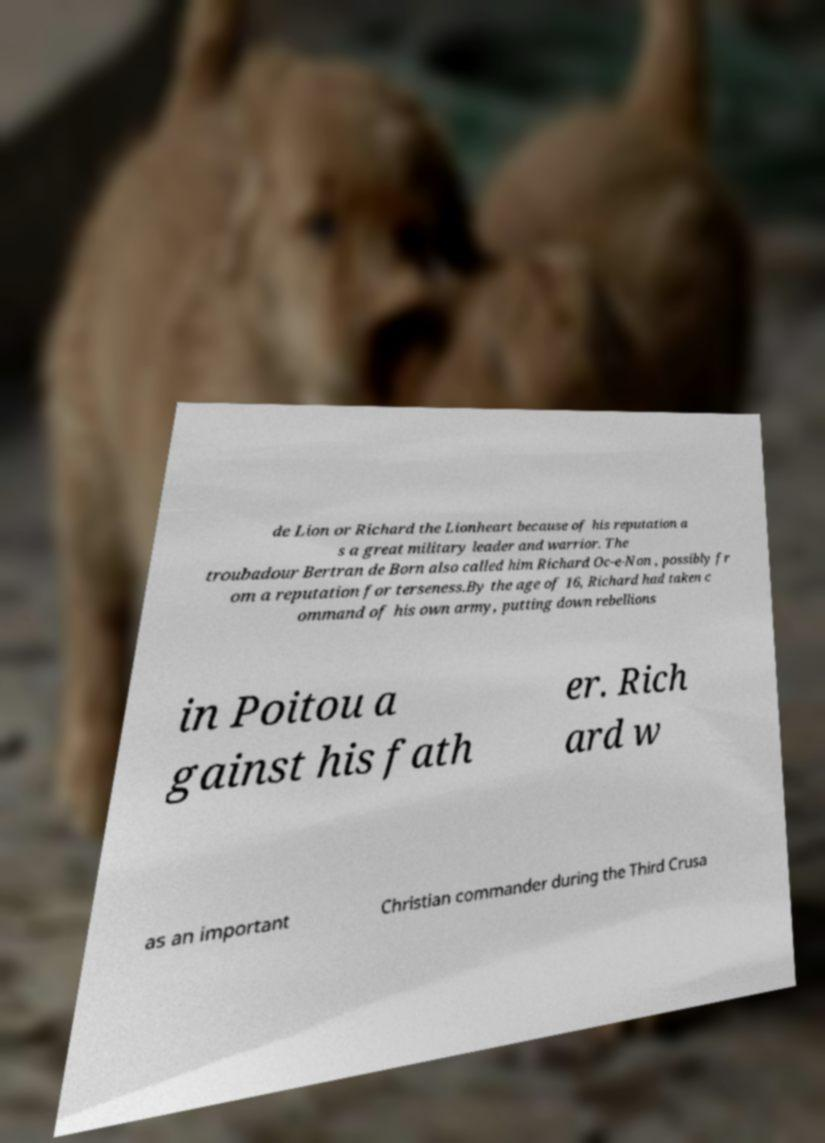Can you read and provide the text displayed in the image?This photo seems to have some interesting text. Can you extract and type it out for me? de Lion or Richard the Lionheart because of his reputation a s a great military leader and warrior. The troubadour Bertran de Born also called him Richard Oc-e-Non , possibly fr om a reputation for terseness.By the age of 16, Richard had taken c ommand of his own army, putting down rebellions in Poitou a gainst his fath er. Rich ard w as an important Christian commander during the Third Crusa 